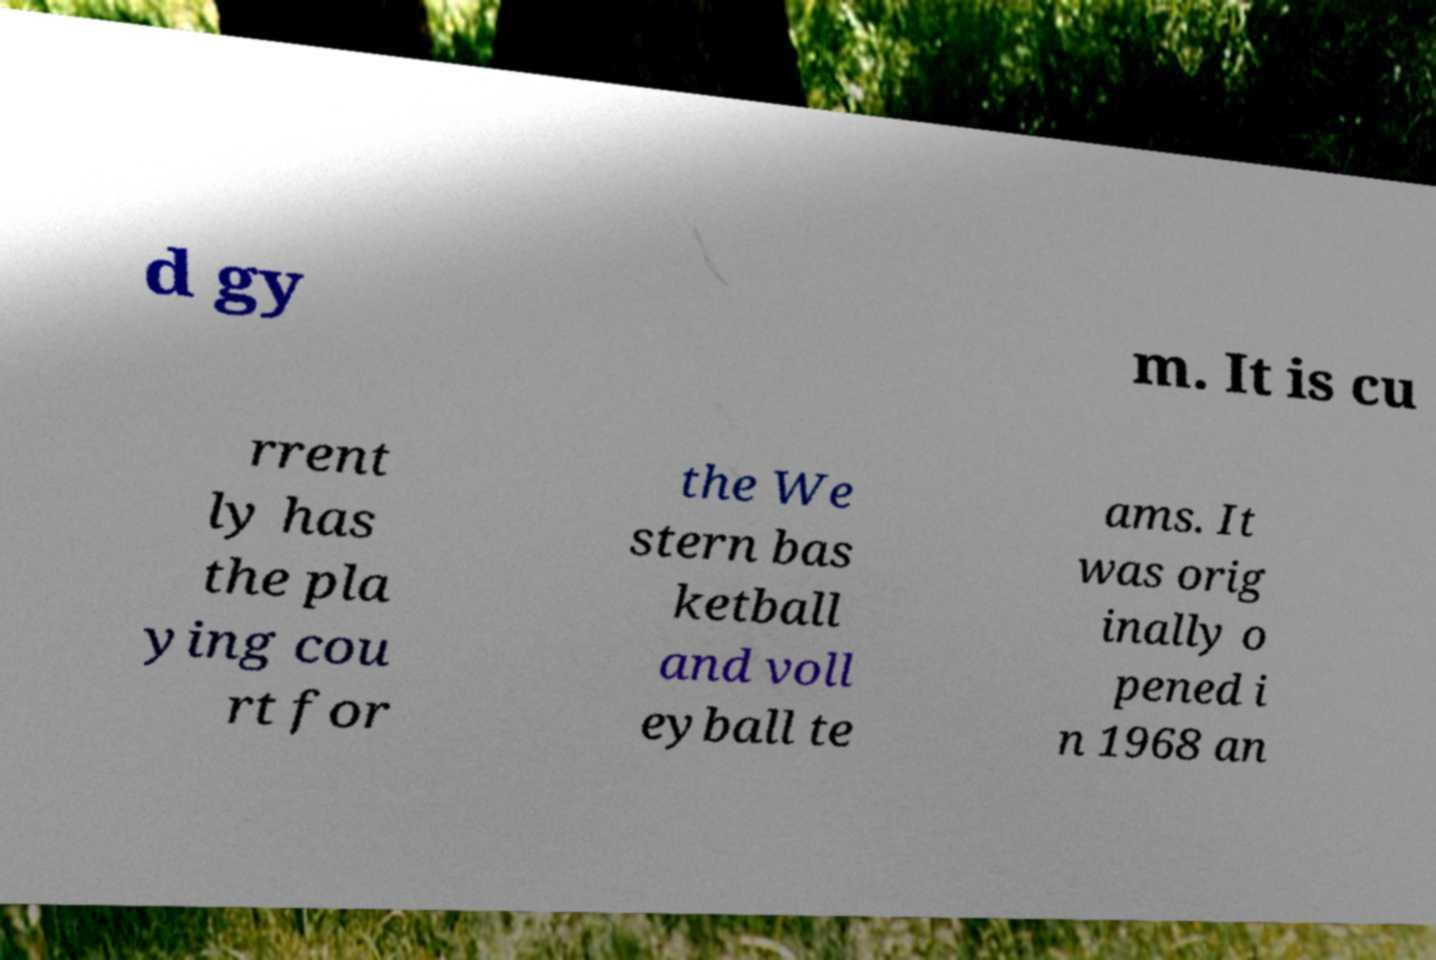Can you read and provide the text displayed in the image?This photo seems to have some interesting text. Can you extract and type it out for me? d gy m. It is cu rrent ly has the pla ying cou rt for the We stern bas ketball and voll eyball te ams. It was orig inally o pened i n 1968 an 